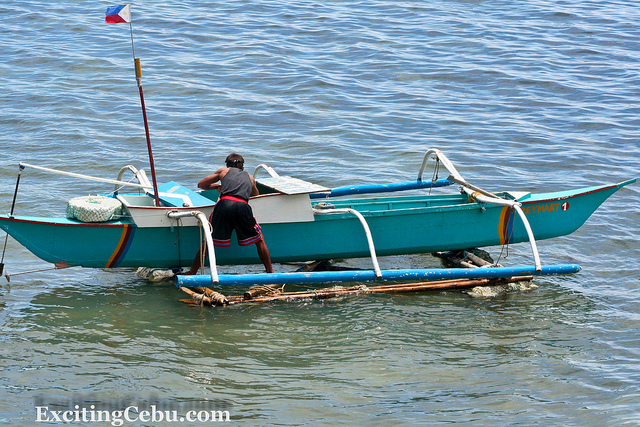Please transcribe the text in this image. 1 EYMART ExcitingCebu.com 